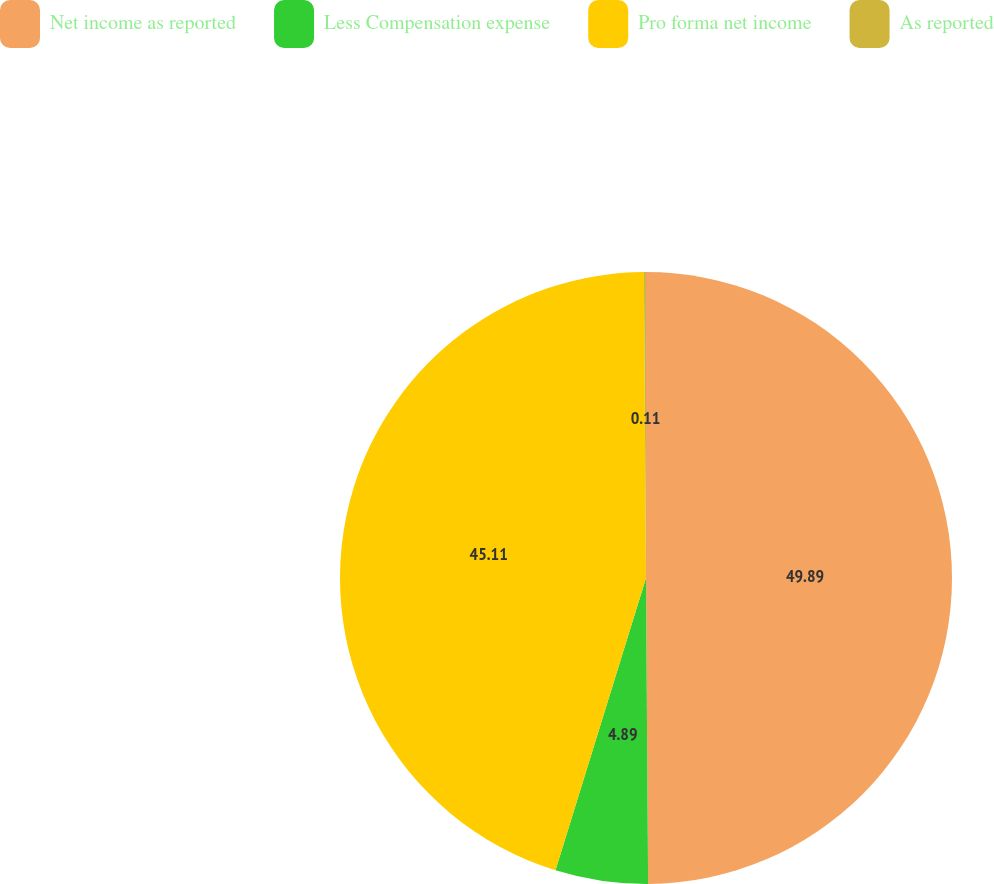<chart> <loc_0><loc_0><loc_500><loc_500><pie_chart><fcel>Net income as reported<fcel>Less Compensation expense<fcel>Pro forma net income<fcel>As reported<nl><fcel>49.89%<fcel>4.89%<fcel>45.11%<fcel>0.11%<nl></chart> 